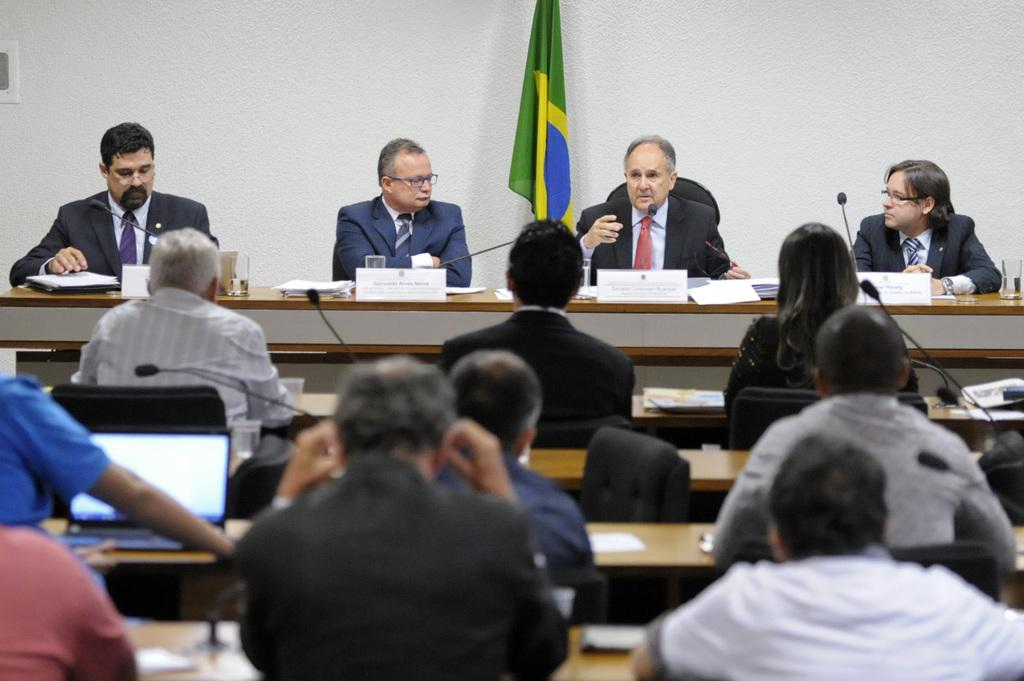What are the people in the image doing? The persons in the image are sitting on chairs. What can be seen on the table in the image? There are many things on the table in the image. What is visible in the background of the image? There is a wall and a flag in the background of the image. What type of dress is the cave wearing in the image? There is no cave or dress present in the image. What is the weight of the persons sitting on chairs in the image? The weight of the persons sitting on chairs cannot be determined from the image alone. 